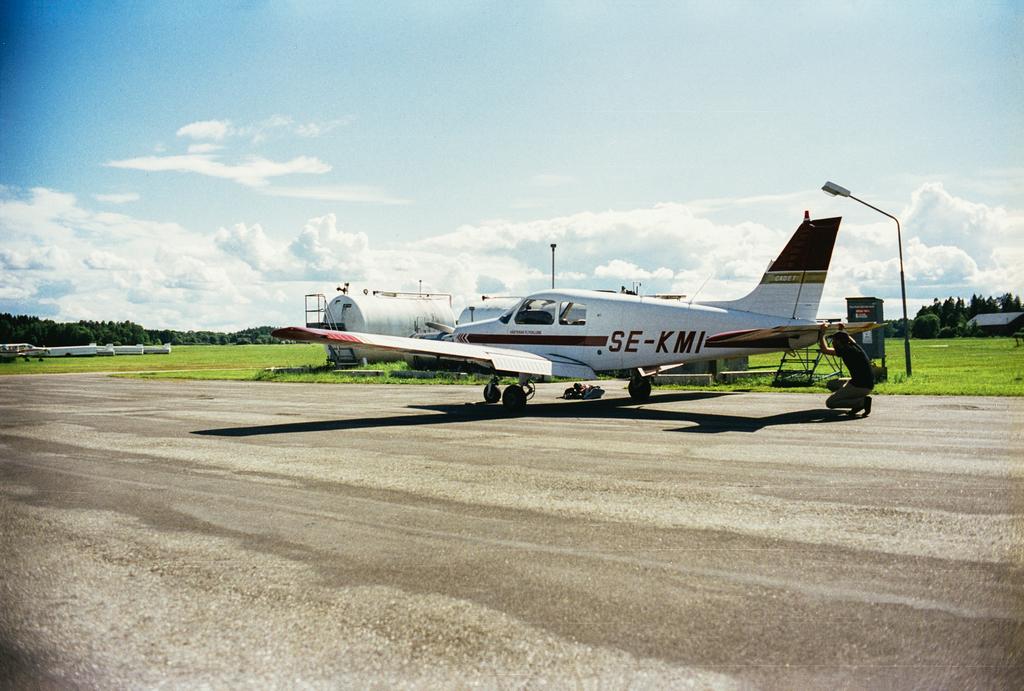What number is the airplane?
Your answer should be compact. Se-kmi. What letters are on the plane?
Your response must be concise. Se-kmi. 